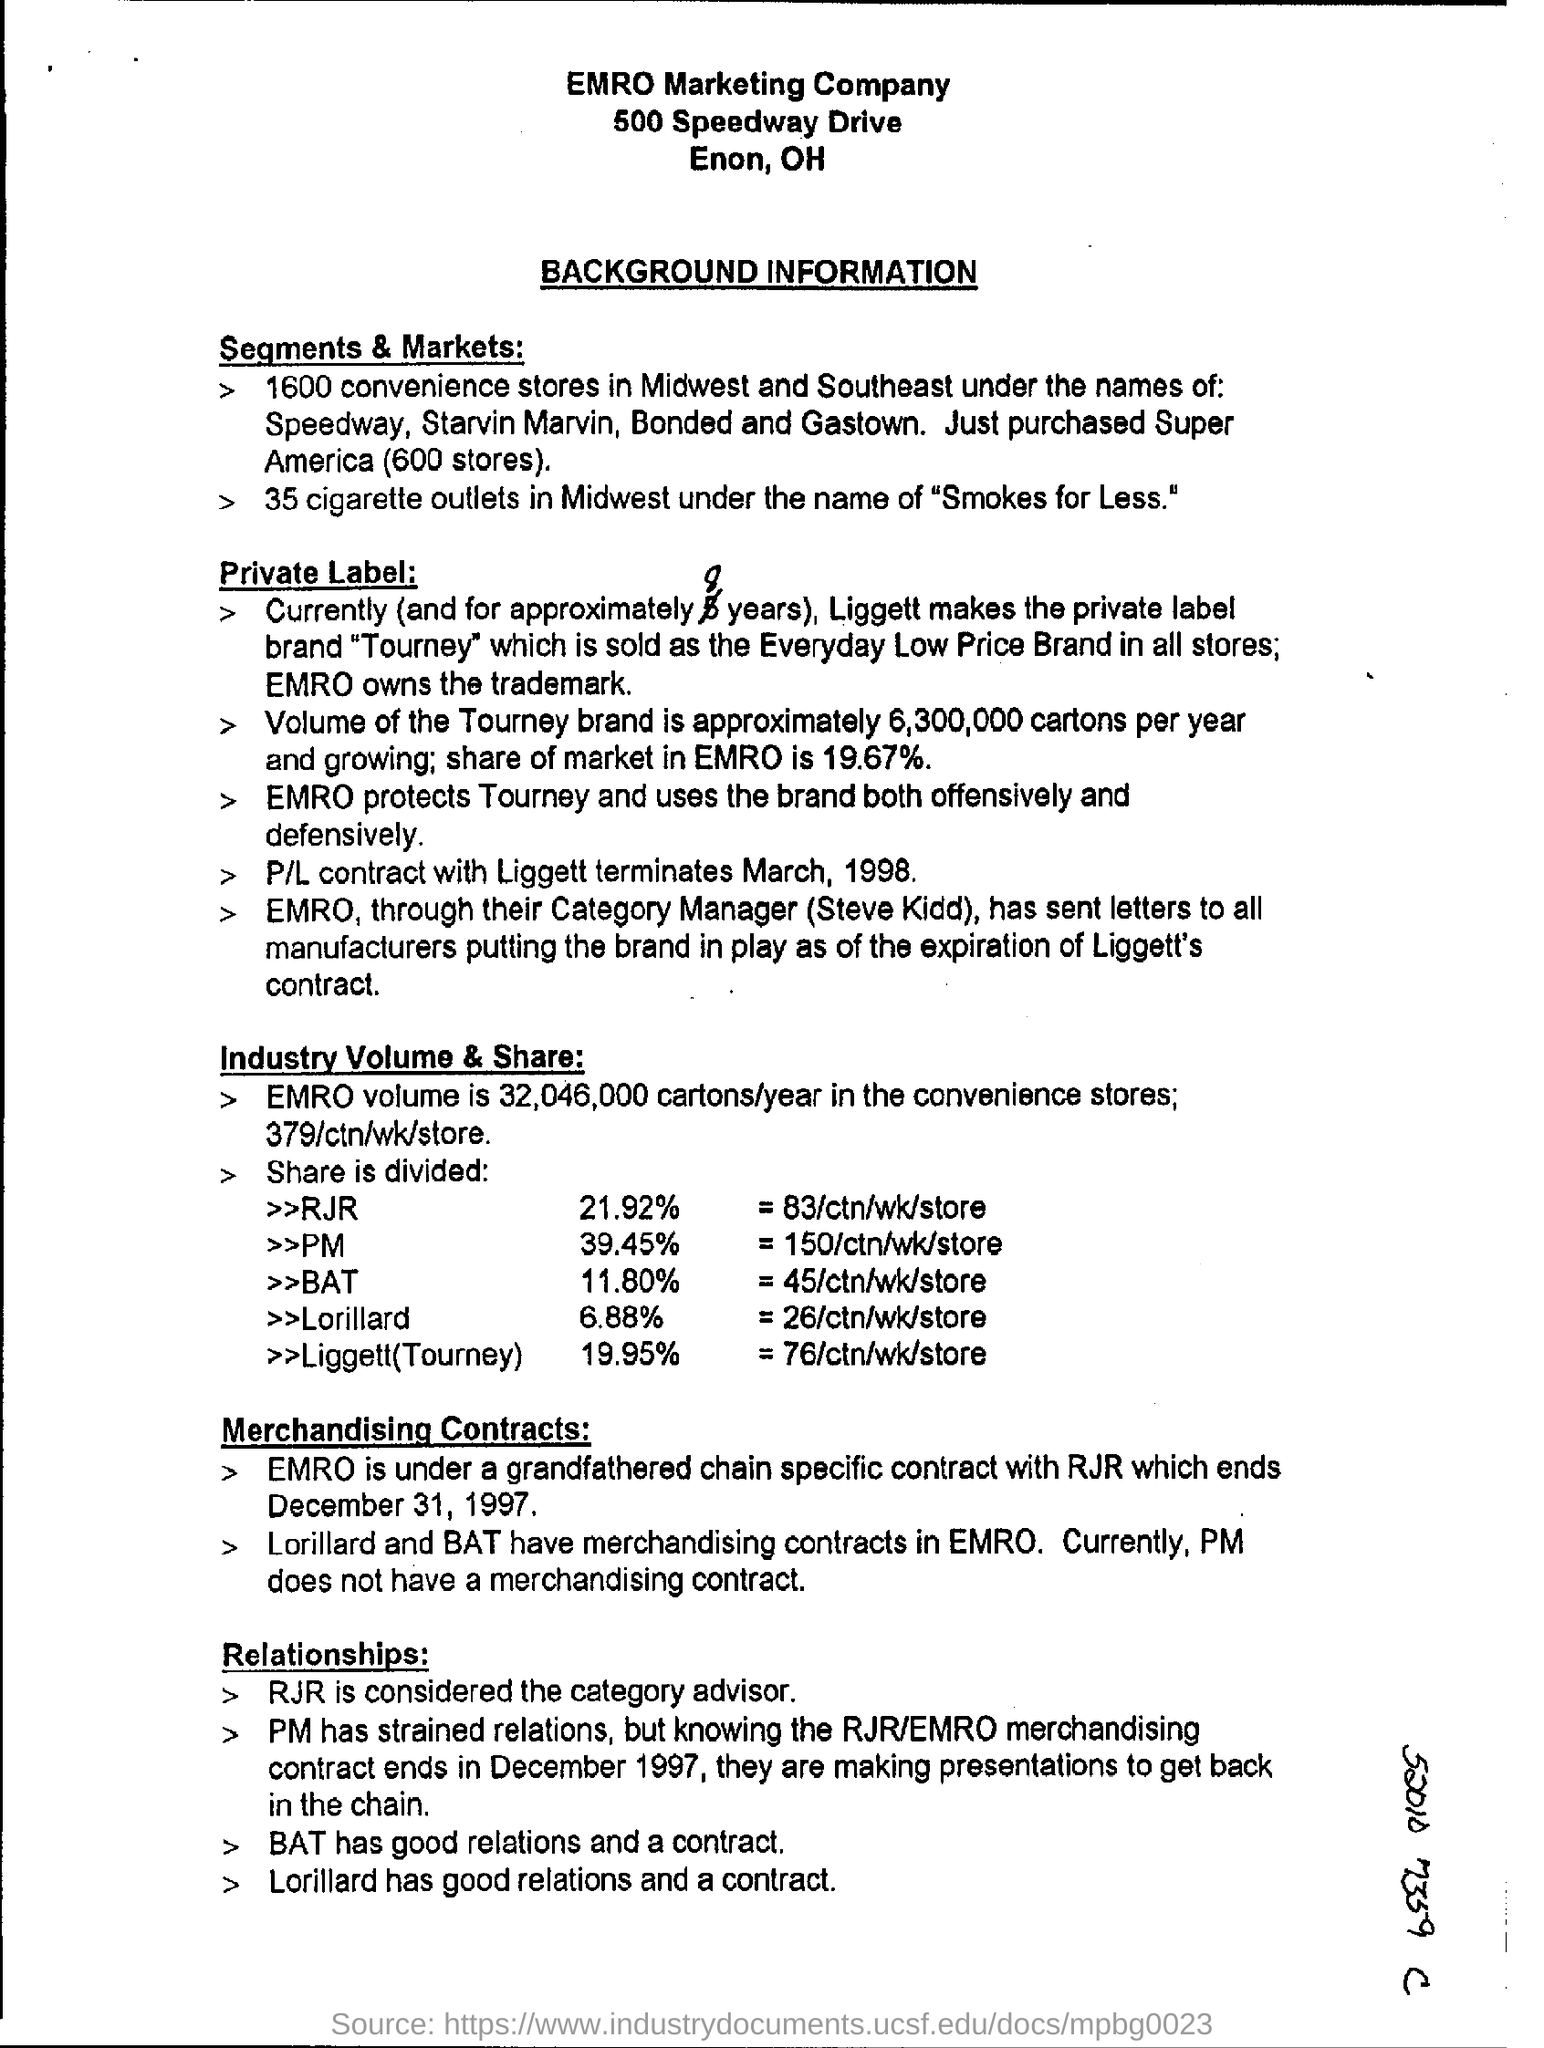What type of information is outlined in this document?
Your answer should be very brief. BACKGROUND INFORMATION. How many cigarette outlets are in Midwest based on 'Segments & Markets:' section?
Provide a short and direct response. 35 cigarette outlets. In what name the cigarette outlets in Midwest is known of ?
Your response must be concise. Smokes for Less. How many convenience stores are in Midwest and Southeast?
Your answer should be very brief. 1600. How much is the share of market value of brand " Tourney" in EMRO mentioned under title 'Private Label:'?
Ensure brevity in your answer.  19.67%. When was P/L contract with Liggett terminated mentioned under "Private Label:"?
Your answer should be compact. March, 1998. How much was EMRO volume in convenience stores per year mentioned under "Industry Volume & Share" ?
Give a very brief answer. 32,046,000 cartons/year. How much % of Share is for RJR stated under "Industry Volume & Share:" ?
Your answer should be very brief. 21.92%. Which brand got a share " = 150/ctn/wk/store"  mentioned under "Industry Volume & Share:" ?
Your response must be concise. PM. Based on sub-heading "Relationships:" , who is considered to the category advisor?
Provide a short and direct response. RJR. 